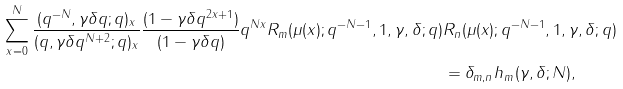<formula> <loc_0><loc_0><loc_500><loc_500>\sum _ { x = 0 } ^ { N } \frac { ( q ^ { - N } , \gamma \delta q ; q ) _ { x } } { ( q , \gamma \delta q ^ { N + 2 } ; q ) _ { x } } \frac { ( 1 - \gamma \delta q ^ { 2 x + 1 } ) } { ( 1 - \gamma \delta q ) } q ^ { N x } R _ { m } ( \mu ( x ) ; q ^ { - N - 1 } , 1 , \gamma , \delta ; q ) & R _ { n } ( \mu ( x ) ; q ^ { - N - 1 } , 1 , \gamma , \delta ; q ) \\ & = \delta _ { m , n } h _ { m } ( \gamma , \delta ; N ) ,</formula> 